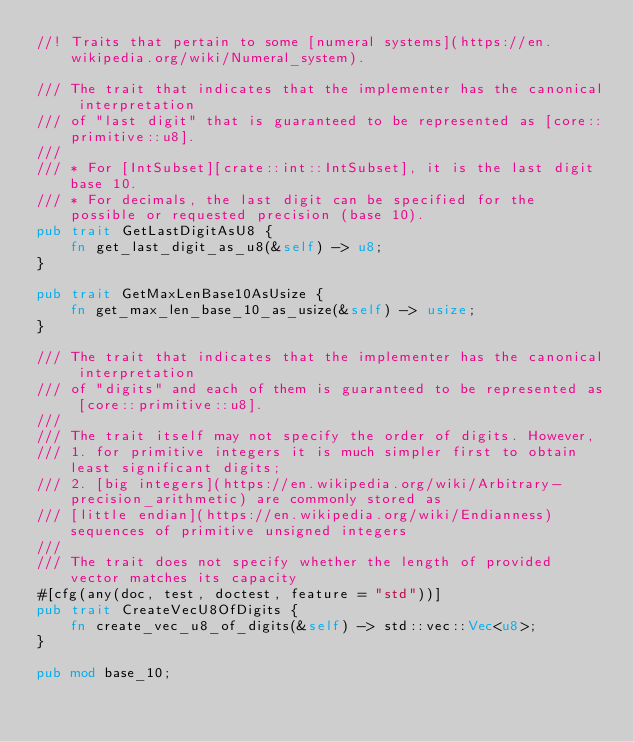<code> <loc_0><loc_0><loc_500><loc_500><_Rust_>//! Traits that pertain to some [numeral systems](https://en.wikipedia.org/wiki/Numeral_system).

/// The trait that indicates that the implementer has the canonical interpretation
/// of "last digit" that is guaranteed to be represented as [core::primitive::u8].
///
/// * For [IntSubset][crate::int::IntSubset], it is the last digit base 10.
/// * For decimals, the last digit can be specified for the possible or requested precision (base 10).
pub trait GetLastDigitAsU8 {
    fn get_last_digit_as_u8(&self) -> u8;
}

pub trait GetMaxLenBase10AsUsize {
    fn get_max_len_base_10_as_usize(&self) -> usize;
}

/// The trait that indicates that the implementer has the canonical interpretation
/// of "digits" and each of them is guaranteed to be represented as [core::primitive::u8].
///
/// The trait itself may not specify the order of digits. However,
/// 1. for primitive integers it is much simpler first to obtain least significant digits;
/// 2. [big integers](https://en.wikipedia.org/wiki/Arbitrary-precision_arithmetic) are commonly stored as
/// [little endian](https://en.wikipedia.org/wiki/Endianness) sequences of primitive unsigned integers
///
/// The trait does not specify whether the length of provided vector matches its capacity
#[cfg(any(doc, test, doctest, feature = "std"))]
pub trait CreateVecU8OfDigits {
    fn create_vec_u8_of_digits(&self) -> std::vec::Vec<u8>;
}

pub mod base_10;
</code> 